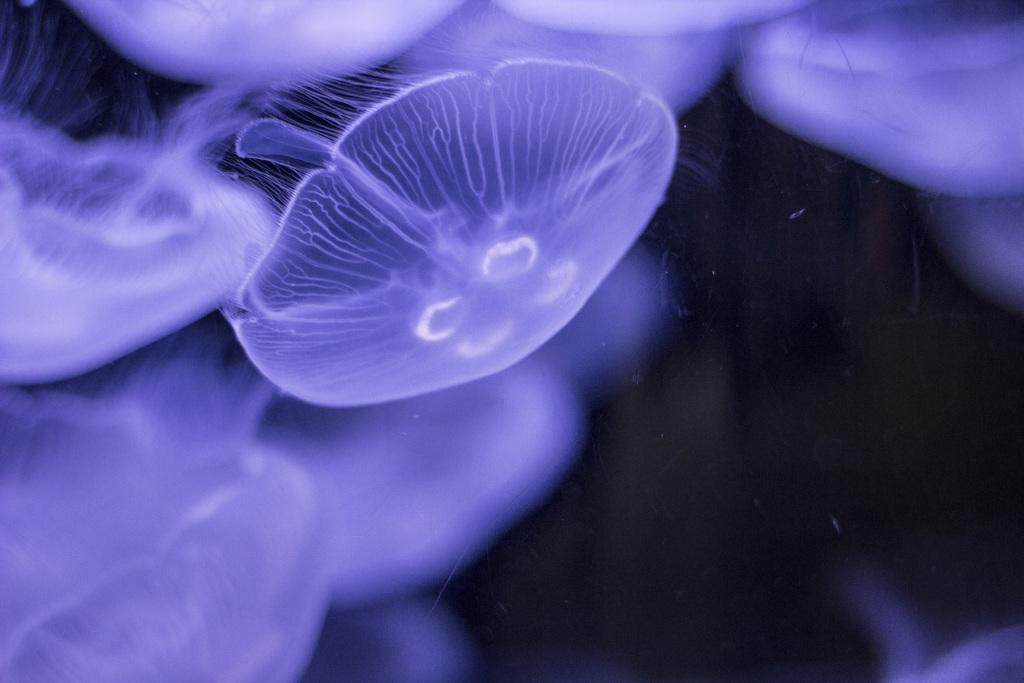What type of marine animals are in the image? There are jellyfish in the image. What is the color of the background in the image? The background of the image is dark. What type of food is the jellyfish using to communicate with the giraffe in the image? There is no giraffe present in the image, and therefore no such interaction can be observed. 